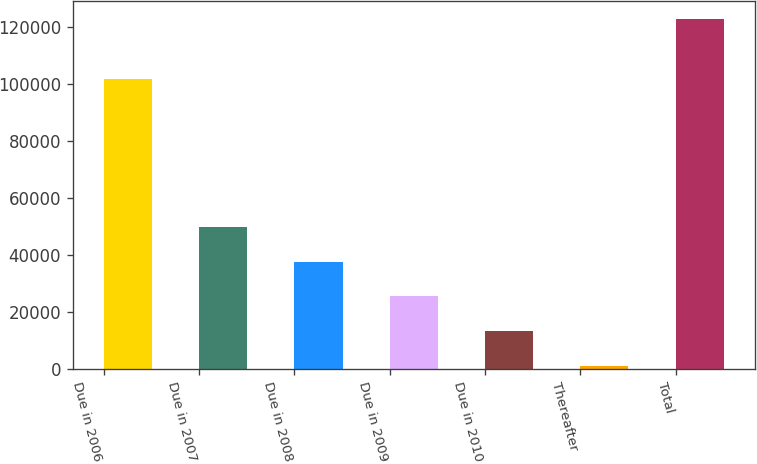Convert chart. <chart><loc_0><loc_0><loc_500><loc_500><bar_chart><fcel>Due in 2006<fcel>Due in 2007<fcel>Due in 2008<fcel>Due in 2009<fcel>Due in 2010<fcel>Thereafter<fcel>Total<nl><fcel>101461<fcel>49759.4<fcel>37600.3<fcel>25441.2<fcel>13282.1<fcel>1123<fcel>122714<nl></chart> 